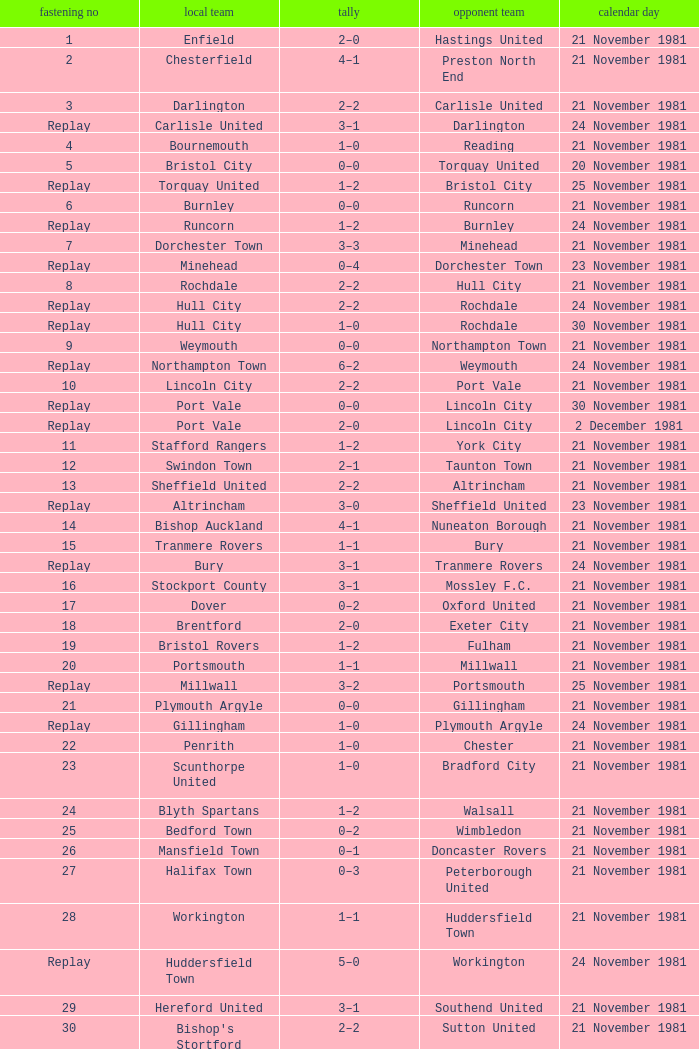On what date was tie number 4? 21 November 1981. 